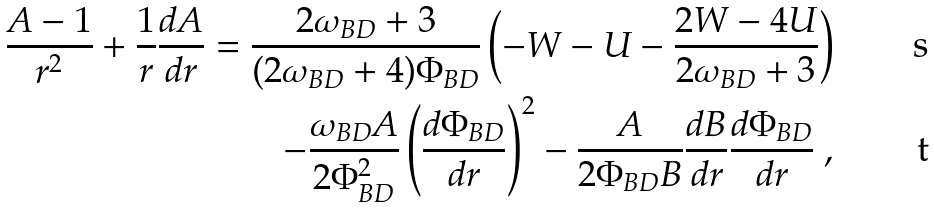Convert formula to latex. <formula><loc_0><loc_0><loc_500><loc_500>\frac { A - 1 } { r ^ { 2 } } + \frac { 1 } { r } \frac { d A } { d r } = \frac { 2 \omega _ { B D } + 3 } { ( 2 \omega _ { B D } + 4 ) \Phi _ { B D } } \left ( - W - U - \frac { 2 W - 4 U } { 2 \omega _ { B D } + 3 } \right ) \\ - \frac { \omega _ { B D } A } { 2 \Phi _ { B D } ^ { 2 } } \left ( \frac { d \Phi _ { B D } } { d r } \right ) ^ { 2 } - \frac { A } { 2 \Phi _ { B D } B } \frac { d B } { d r } \frac { d \Phi _ { B D } } { d r } \ ,</formula> 